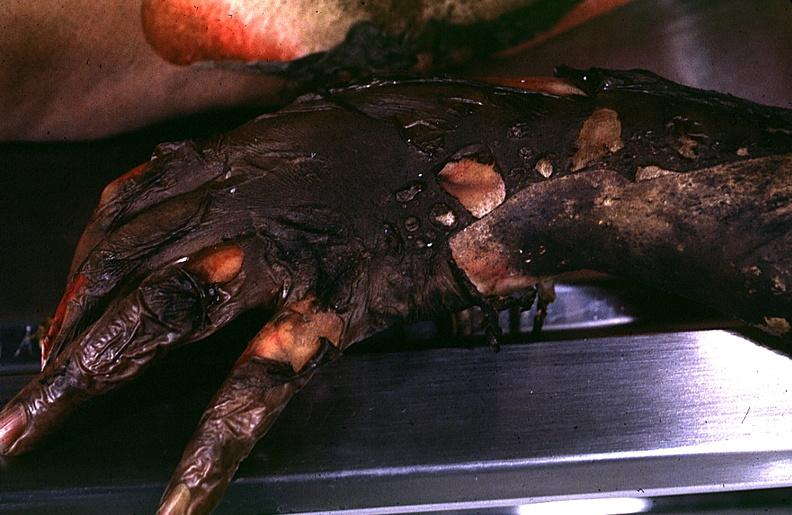what burn?
Answer the question using a single word or phrase. Thermal 